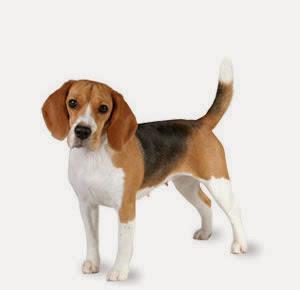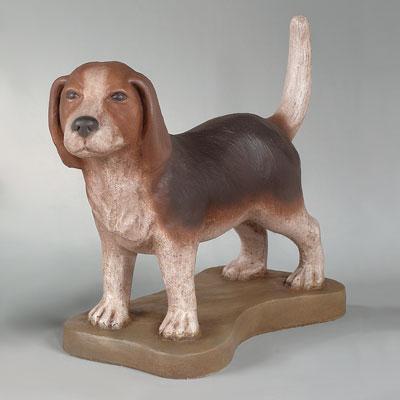The first image is the image on the left, the second image is the image on the right. Analyze the images presented: Is the assertion "In one of the images there is a real dog whose tail is standing up straight." valid? Answer yes or no. Yes. 